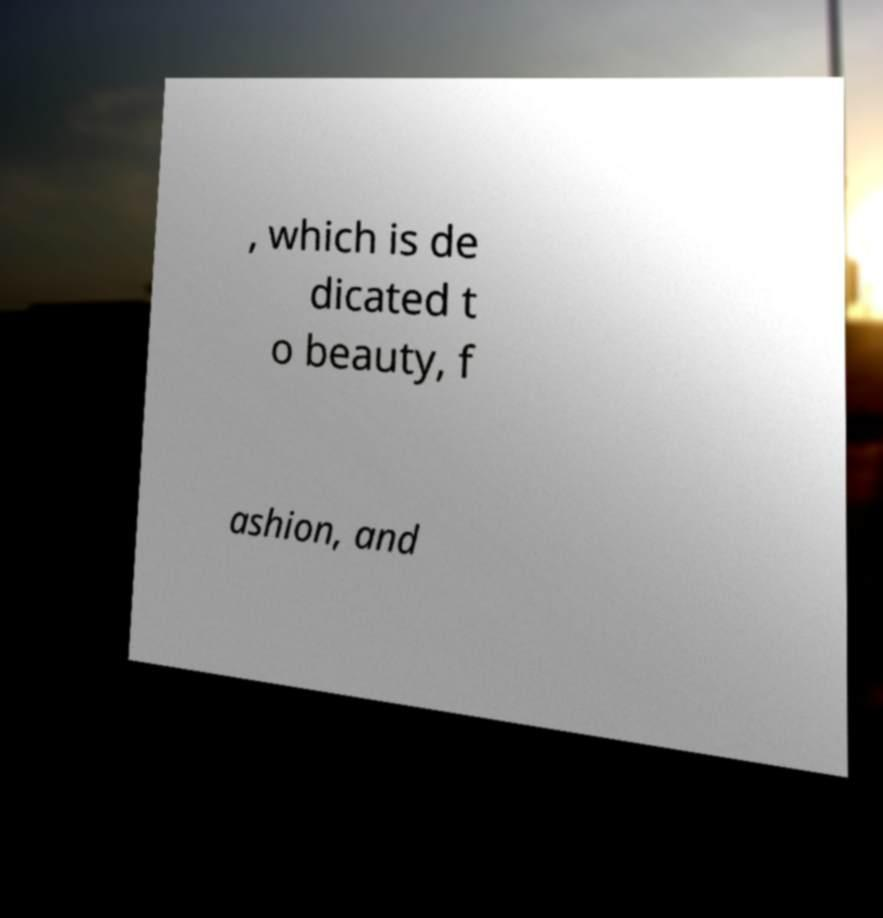There's text embedded in this image that I need extracted. Can you transcribe it verbatim? , which is de dicated t o beauty, f ashion, and 